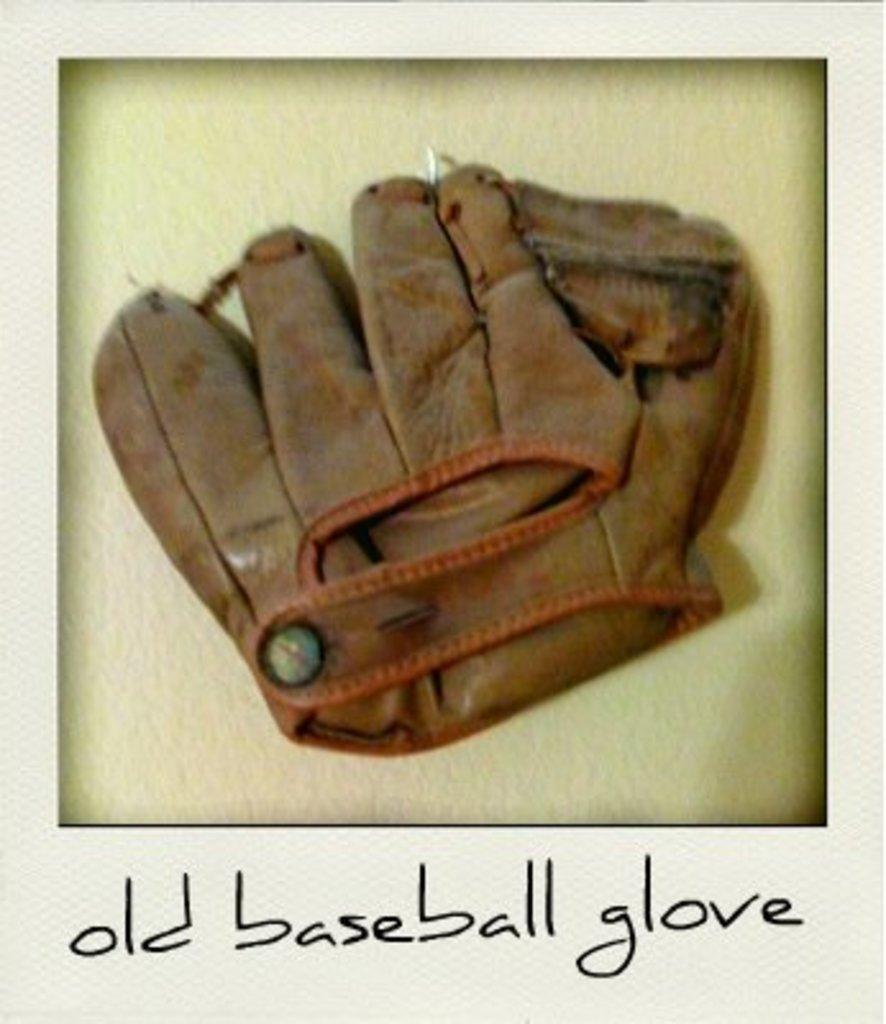Please provide a concise description of this image. In this picture we can see the photo of an old baseball glove in brown color. The background is in lime green color. 